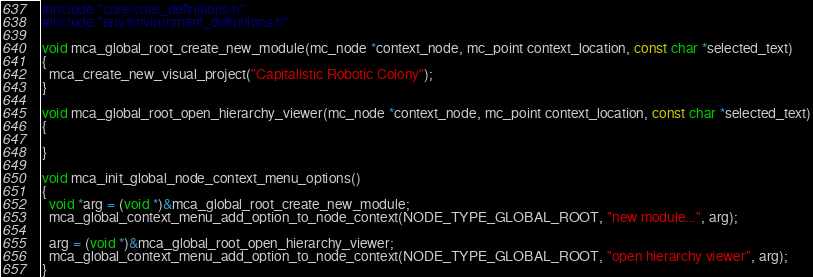<code> <loc_0><loc_0><loc_500><loc_500><_C_>
#include "core/core_definitions.h"
#include "env/environment_definitions.h"

void mca_global_root_create_new_module(mc_node *context_node, mc_point context_location, const char *selected_text)
{
  mca_create_new_visual_project("Capitalistic Robotic Colony");
}

void mca_global_root_open_hierarchy_viewer(mc_node *context_node, mc_point context_location, const char *selected_text)
{
  
}

void mca_init_global_node_context_menu_options()
{
  void *arg = (void *)&mca_global_root_create_new_module;
  mca_global_context_menu_add_option_to_node_context(NODE_TYPE_GLOBAL_ROOT, "new module...", arg);

  arg = (void *)&mca_global_root_open_hierarchy_viewer;
  mca_global_context_menu_add_option_to_node_context(NODE_TYPE_GLOBAL_ROOT, "open hierarchy viewer", arg);
}</code> 